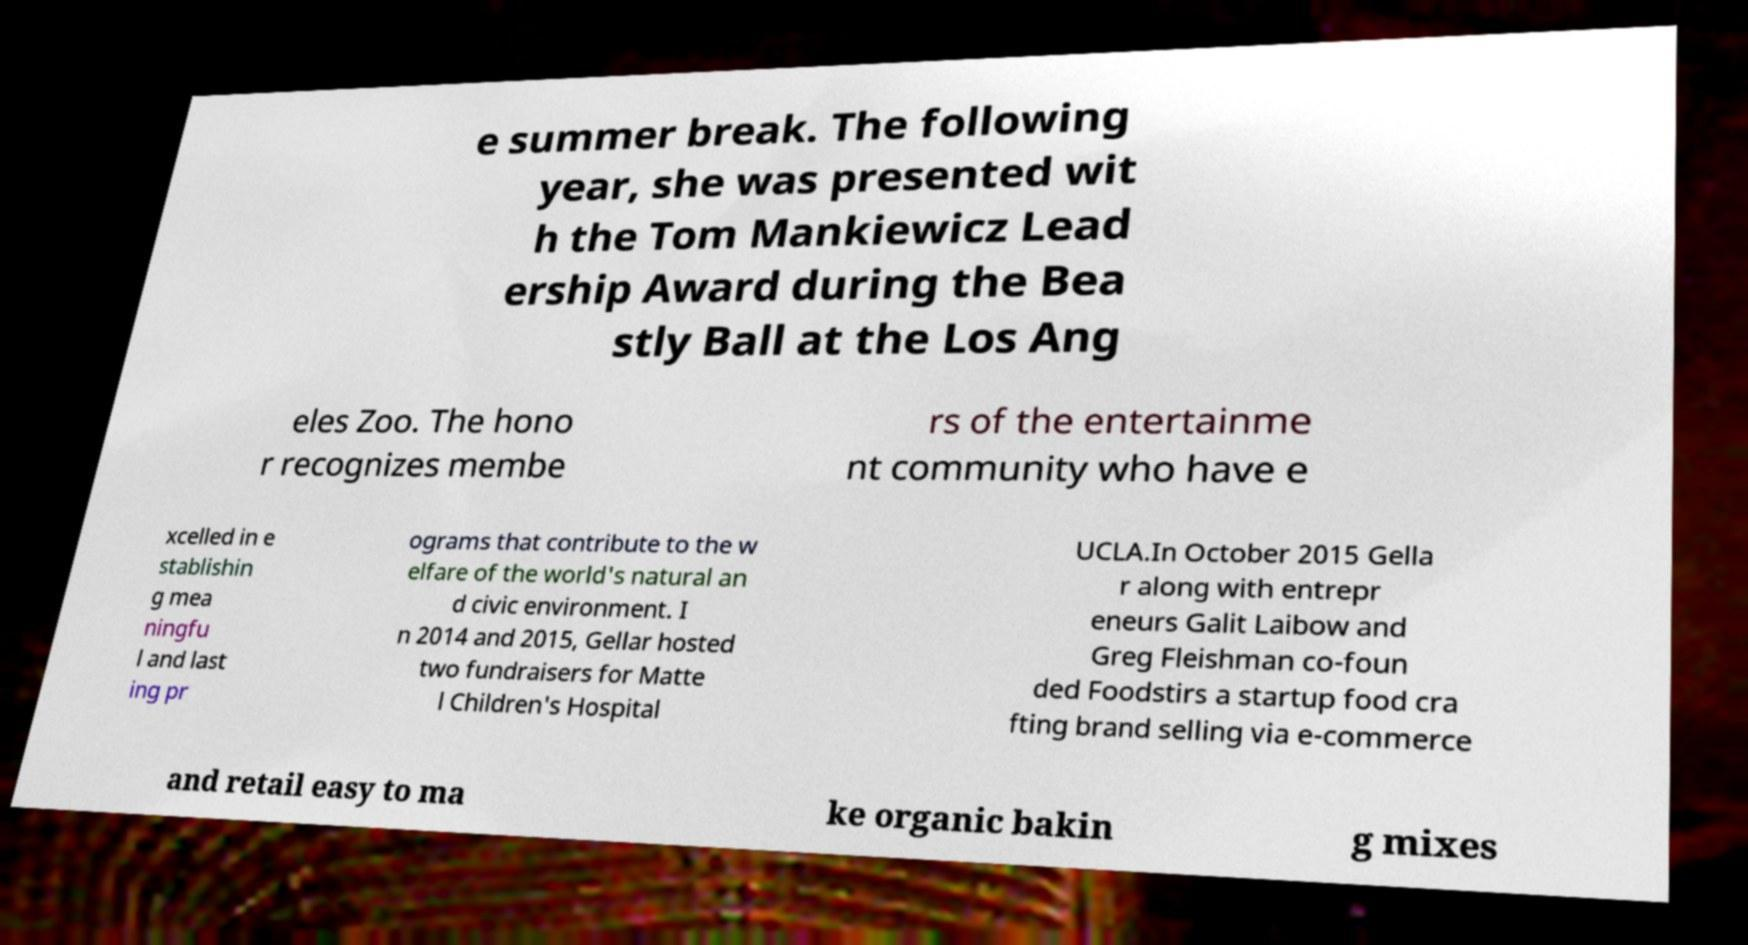I need the written content from this picture converted into text. Can you do that? e summer break. The following year, she was presented wit h the Tom Mankiewicz Lead ership Award during the Bea stly Ball at the Los Ang eles Zoo. The hono r recognizes membe rs of the entertainme nt community who have e xcelled in e stablishin g mea ningfu l and last ing pr ograms that contribute to the w elfare of the world's natural an d civic environment. I n 2014 and 2015, Gellar hosted two fundraisers for Matte l Children's Hospital UCLA.In October 2015 Gella r along with entrepr eneurs Galit Laibow and Greg Fleishman co-foun ded Foodstirs a startup food cra fting brand selling via e-commerce and retail easy to ma ke organic bakin g mixes 